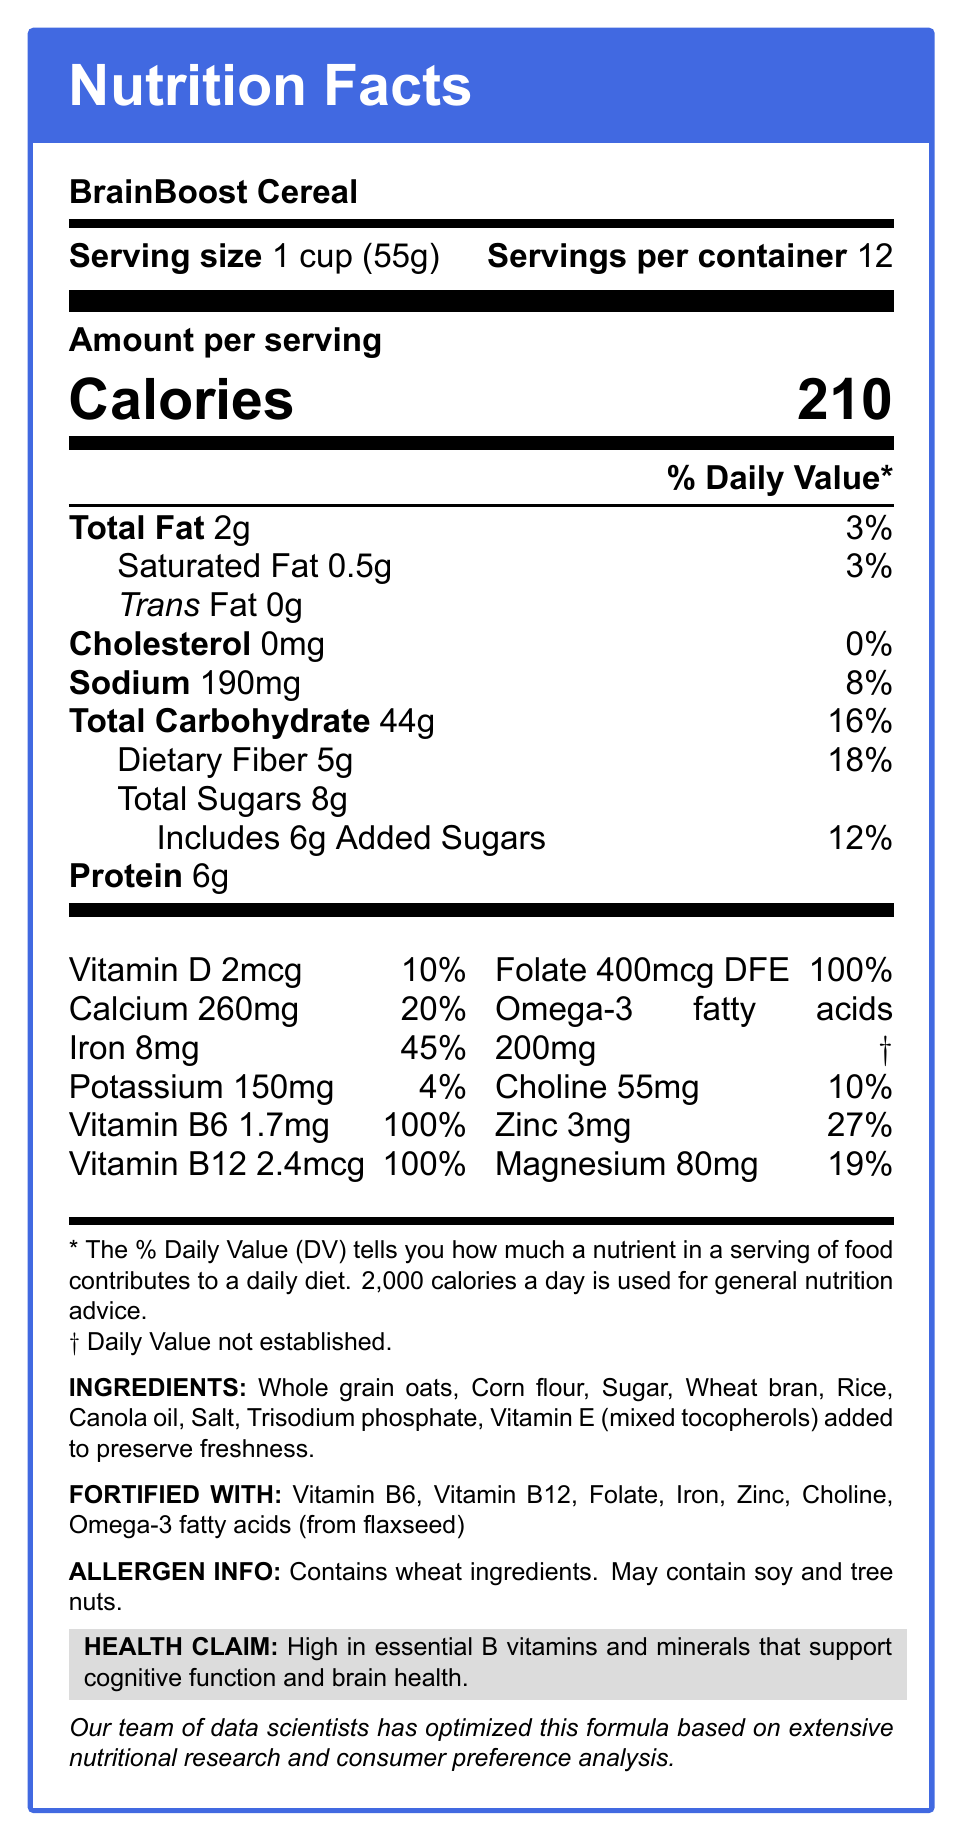What is the serving size of BrainBoost Cereal? This information is clearly provided in the document under "Serving size."
Answer: 1 cup (55g) How many servings are there in one container? The document states "Servings per container: 12."
Answer: 12 What is the daily value percentage of Vitamin B6 provided by one serving? The document lists the daily value percentage for Vitamin B6 as 100%.
Answer: 100% What micronutrient has the highest daily value percentage in BrainBoost Cereal? The document shows Iron at 45%, which is the highest daily value percentage among the listed micronutrients.
Answer: Iron Name two ingredients used to preserve freshness in BrainBoost Cereal. The ingredients section lists "Vitamin E (mixed tocopherols) added to preserve freshness."
Answer: Vitamin E (mixed tocopherols) What cognitive benefits does BrainBoost Cereal claim to offer? The health claim section explicitly states these benefits.
Answer: High in essential B vitamins and minerals that support cognitive function and brain health. What is the amount of protein in one serving of BrainBoost Cereal? This information is listed under the nutrition facts as "Protein 6g."
Answer: 6g Which of the following is not a listed ingredient in BrainBoost Cereal? A. Whole grain oats B. Sugar C. Almonds D. Canola oil The ingredients listed are whole grain oats, corn flour, sugar, wheat bran, rice, canola oil, salt, and trisodium phosphate. Almonds are not mentioned.
Answer: C What is the daily value percentage for Omega-3 fatty acids? A. 10% B. 20% C. 27% D. Not established The document footnotes Omega-3 fatty acids with a "†" indicating the daily value is not established.
Answer: D Is BrainBoost Cereal gluten-free? The cereal contains wheat ingredients, which means it is not gluten-free.
Answer: No Summarize the main idea of the BrainBoost Cereal Nutrition Facts Label. The summary captures the primary purpose and key details from the nutrition facts label, including the focus on cognitive benefits, serving size, ingredients, and nutritional content.
Answer: BrainBoost Cereal is a vitamin-fortified breakfast cereal designed to support cognitive function and brain health. It provides essential B vitamins and minerals such as Vitamin B6, Vitamin B12, folate, and iron. The serving size is 1 cup (55g) with 12 servings per container. Key ingredients include whole grain oats and wheat bran along with other whole grains and preservatives. How much potassium does one serving of BrainBoost Cereal provide? This information is located under the nutrition facts section listing "Potassium 150mg."
Answer: 150mg What type of ingredient in BrainBoost Cereal may pose allergen risks to some consumers? The allergen information states that it contains wheat ingredients and may contain soy and tree nuts.
Answer: Wheat ingredients, soy, and tree nuts List one nutrient that does not have a daily value established. The footnote indicates that the daily value for Omega-3 fatty acids is not established.
Answer: Omega-3 fatty acids What is the percentage of daily value for dietary fiber in one serving? The nutrition facts list dietary fiber with a daily value percentage of 18%.
Answer: 18% How much of the daily value of iron is provided per serving of this cereal? The document lists iron with a daily value of 45%.
Answer: 45% What does "DFE" stand for in the context of folate measurements? The document does not provide an explanation or full form for "DFE"; hence, this information cannot be determined from the visual information in the document.
Answer: Cannot be determined 